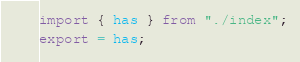Convert code to text. <code><loc_0><loc_0><loc_500><loc_500><_TypeScript_>import { has } from "./index";
export = has;
</code> 